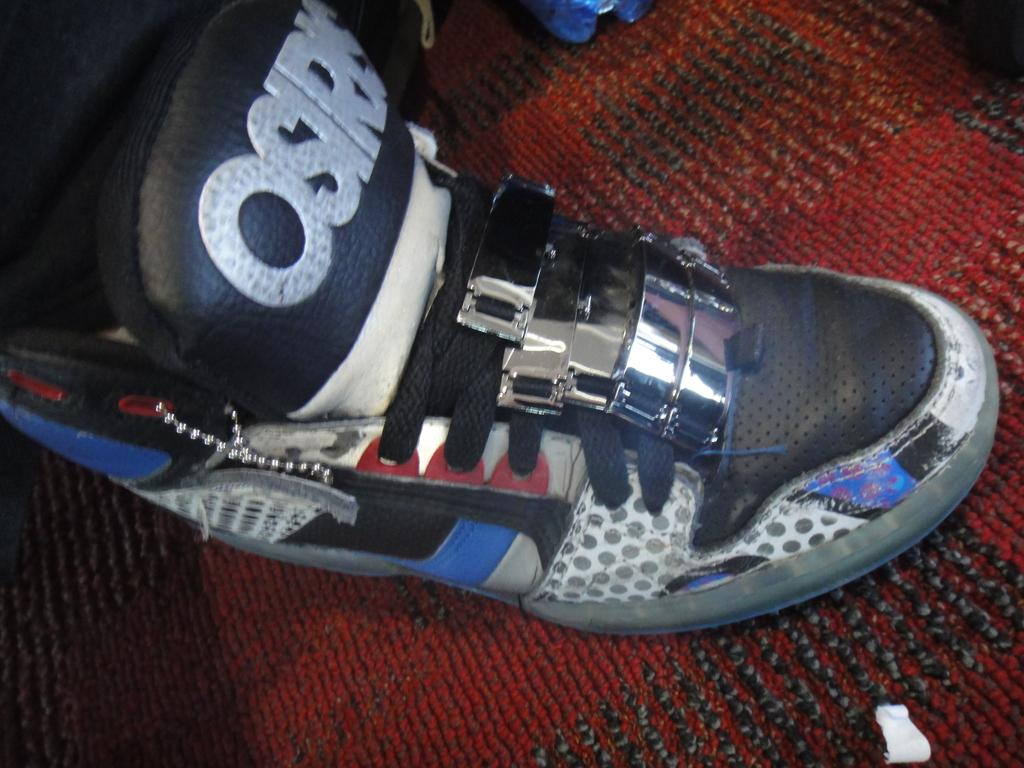<image>
Summarize the visual content of the image. A person is wearing an Osiris shoe on their right foot. 